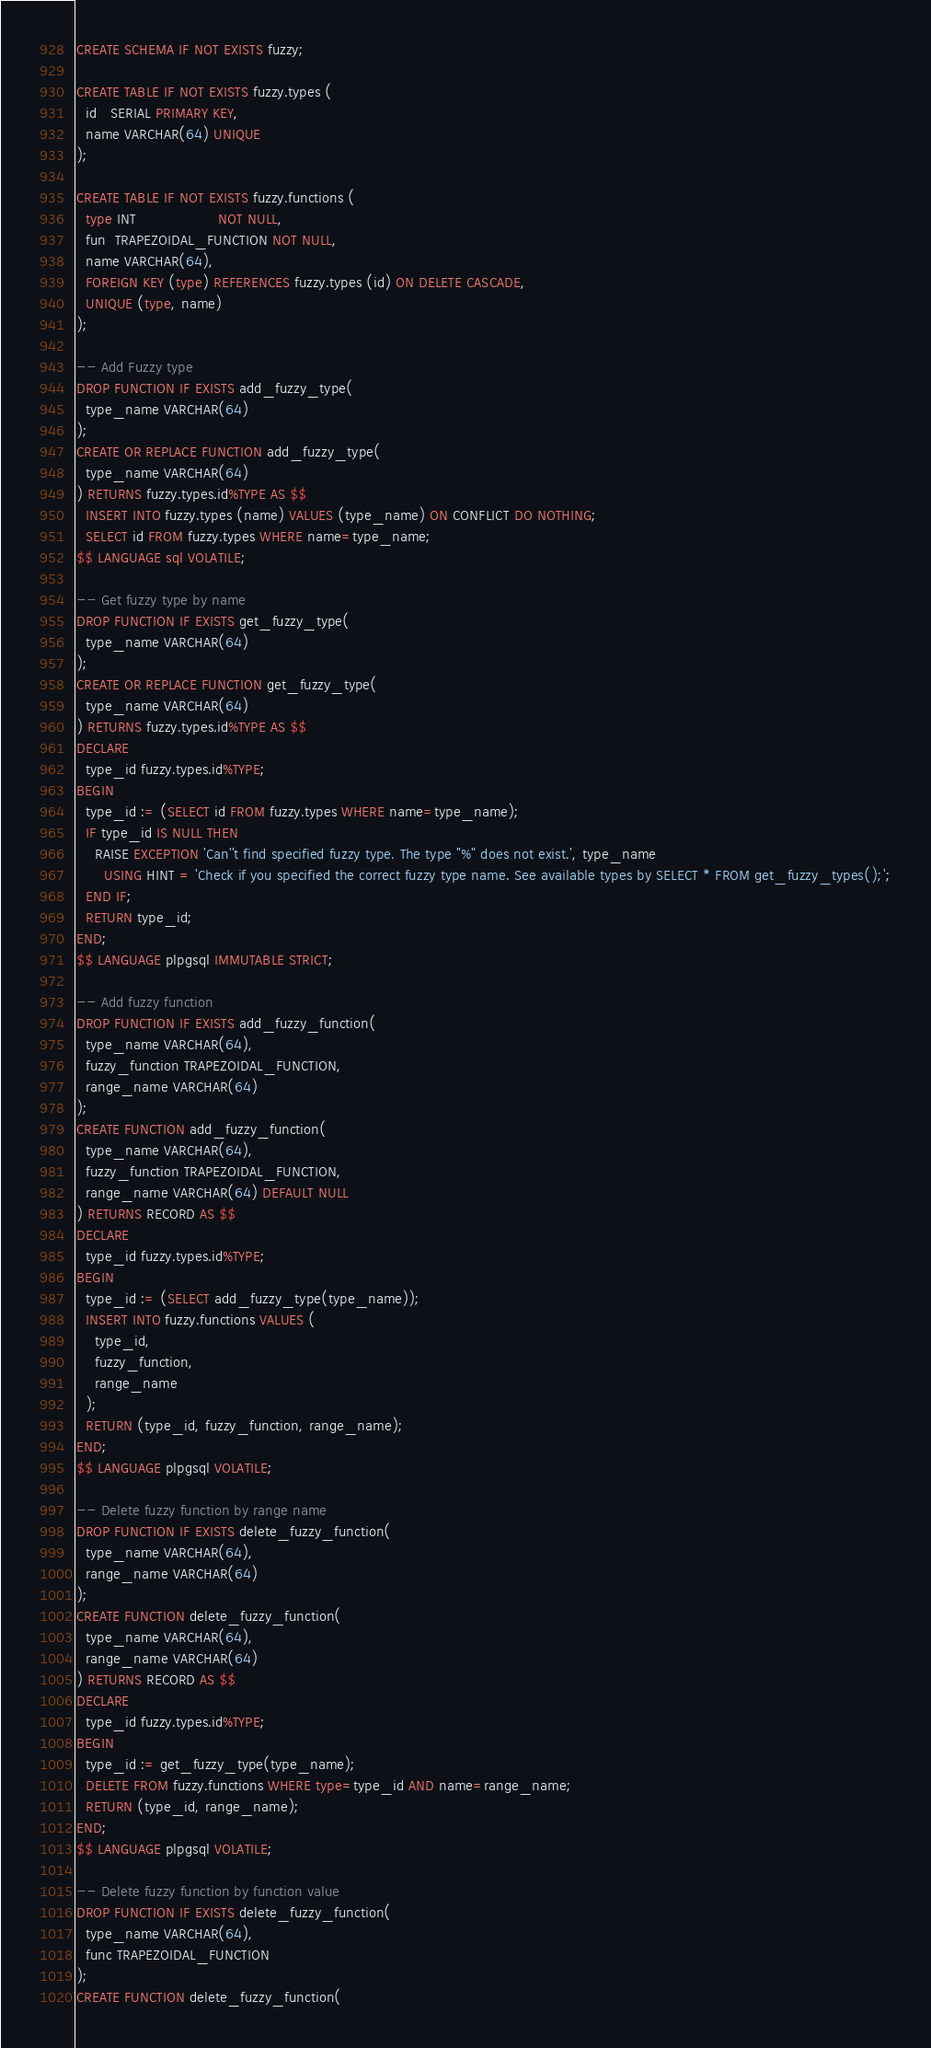Convert code to text. <code><loc_0><loc_0><loc_500><loc_500><_SQL_>CREATE SCHEMA IF NOT EXISTS fuzzy;

CREATE TABLE IF NOT EXISTS fuzzy.types (
  id   SERIAL PRIMARY KEY,
  name VARCHAR(64) UNIQUE
);

CREATE TABLE IF NOT EXISTS fuzzy.functions (
  type INT                  NOT NULL,
  fun  TRAPEZOIDAL_FUNCTION NOT NULL,
  name VARCHAR(64),
  FOREIGN KEY (type) REFERENCES fuzzy.types (id) ON DELETE CASCADE,
  UNIQUE (type, name)
);

-- Add Fuzzy type
DROP FUNCTION IF EXISTS add_fuzzy_type(
  type_name VARCHAR(64)
);
CREATE OR REPLACE FUNCTION add_fuzzy_type(
  type_name VARCHAR(64)
) RETURNS fuzzy.types.id%TYPE AS $$
  INSERT INTO fuzzy.types (name) VALUES (type_name) ON CONFLICT DO NOTHING;
  SELECT id FROM fuzzy.types WHERE name=type_name;
$$ LANGUAGE sql VOLATILE;

-- Get fuzzy type by name
DROP FUNCTION IF EXISTS get_fuzzy_type(
  type_name VARCHAR(64)
);
CREATE OR REPLACE FUNCTION get_fuzzy_type(
  type_name VARCHAR(64)
) RETURNS fuzzy.types.id%TYPE AS $$
DECLARE
  type_id fuzzy.types.id%TYPE;
BEGIN
  type_id := (SELECT id FROM fuzzy.types WHERE name=type_name);
  IF type_id IS NULL THEN
    RAISE EXCEPTION 'Can''t find specified fuzzy type. The type "%" does not exist.', type_name
      USING HINT = 'Check if you specified the correct fuzzy type name. See available types by SELECT * FROM get_fuzzy_types();';
  END IF;
  RETURN type_id;
END;
$$ LANGUAGE plpgsql IMMUTABLE STRICT;

-- Add fuzzy function
DROP FUNCTION IF EXISTS add_fuzzy_function(
  type_name VARCHAR(64),
  fuzzy_function TRAPEZOIDAL_FUNCTION,
  range_name VARCHAR(64)
);
CREATE FUNCTION add_fuzzy_function(
  type_name VARCHAR(64),
  fuzzy_function TRAPEZOIDAL_FUNCTION,
  range_name VARCHAR(64) DEFAULT NULL
) RETURNS RECORD AS $$
DECLARE
  type_id fuzzy.types.id%TYPE;
BEGIN
  type_id := (SELECT add_fuzzy_type(type_name));
  INSERT INTO fuzzy.functions VALUES (
    type_id,
    fuzzy_function,
    range_name
  );
  RETURN (type_id, fuzzy_function, range_name);
END;
$$ LANGUAGE plpgsql VOLATILE;

-- Delete fuzzy function by range name
DROP FUNCTION IF EXISTS delete_fuzzy_function(
  type_name VARCHAR(64),
  range_name VARCHAR(64)
);
CREATE FUNCTION delete_fuzzy_function(
  type_name VARCHAR(64),
  range_name VARCHAR(64)
) RETURNS RECORD AS $$
DECLARE
  type_id fuzzy.types.id%TYPE;
BEGIN
  type_id := get_fuzzy_type(type_name);
  DELETE FROM fuzzy.functions WHERE type=type_id AND name=range_name;
  RETURN (type_id, range_name);
END;
$$ LANGUAGE plpgsql VOLATILE;

-- Delete fuzzy function by function value
DROP FUNCTION IF EXISTS delete_fuzzy_function(
  type_name VARCHAR(64),
  func TRAPEZOIDAL_FUNCTION
);
CREATE FUNCTION delete_fuzzy_function(</code> 